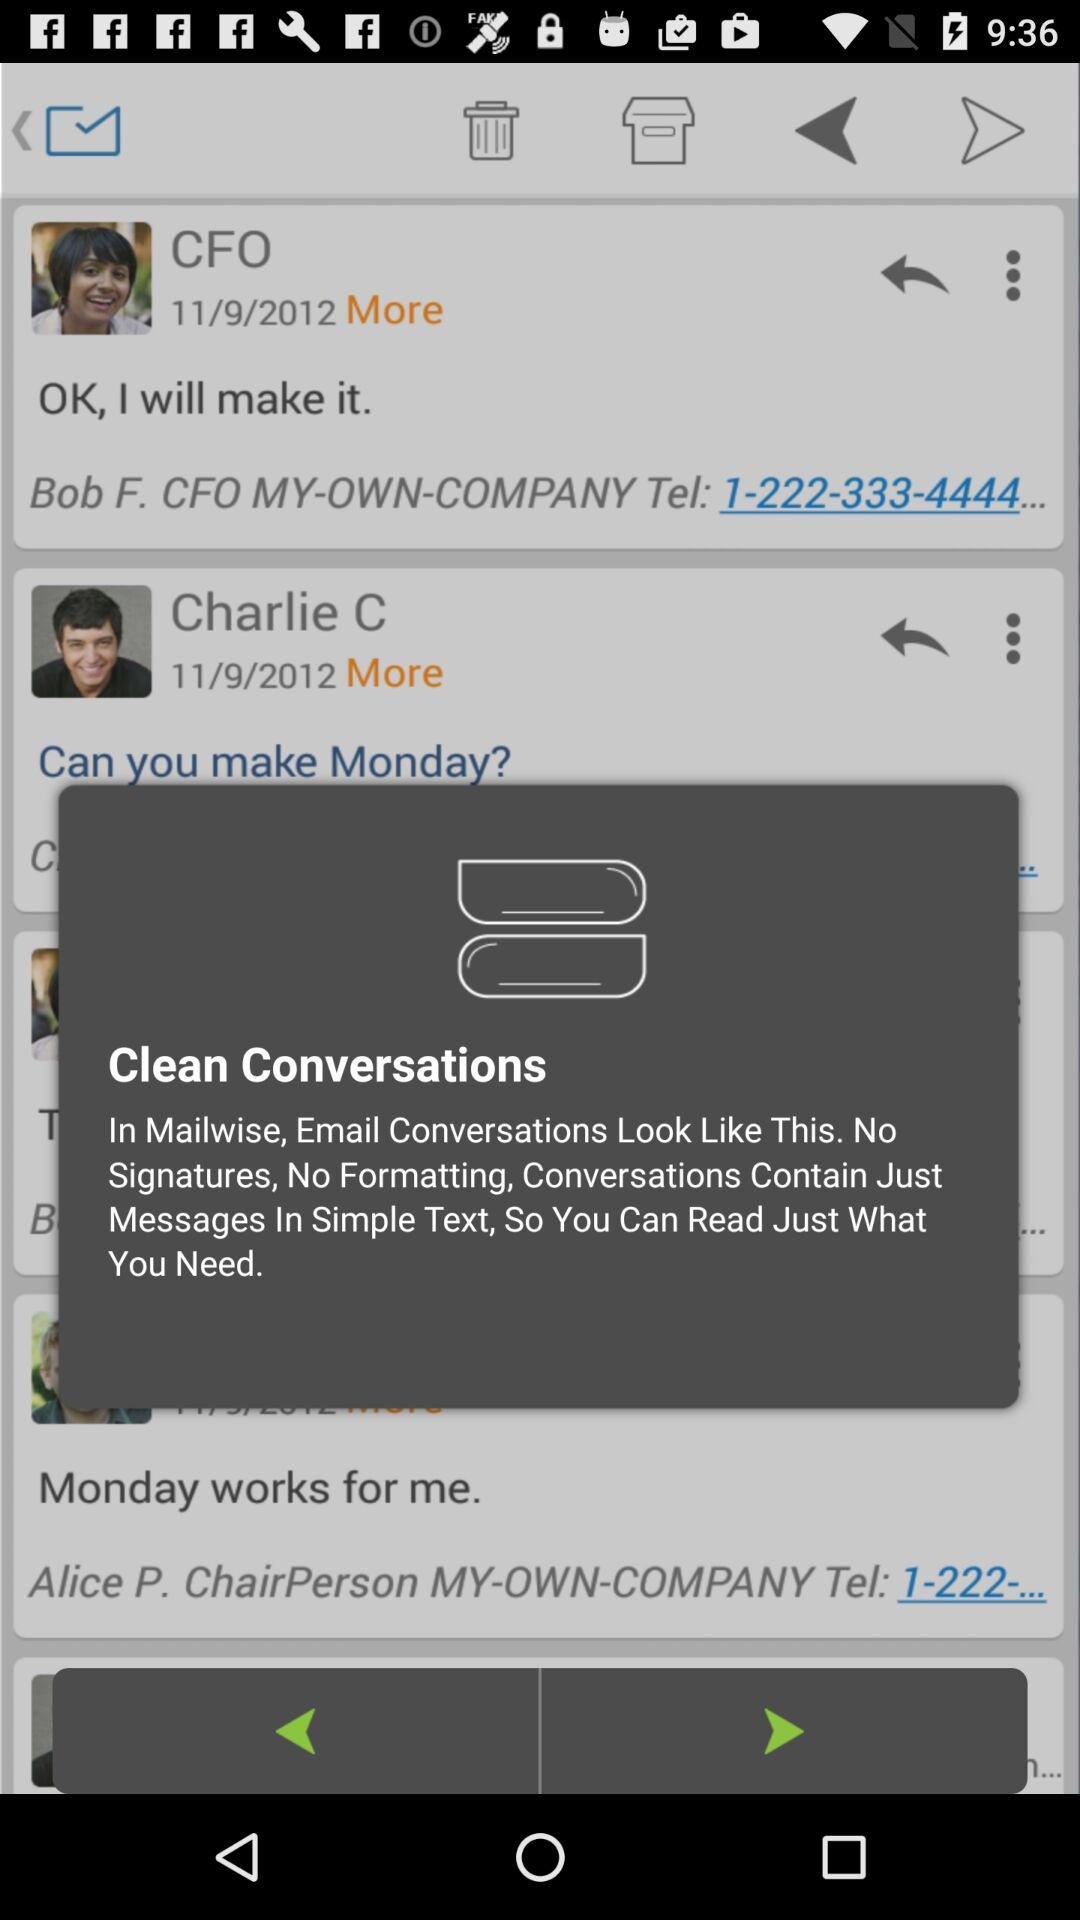When did the CFO comment? The CFO comment on 11/9/2012. 